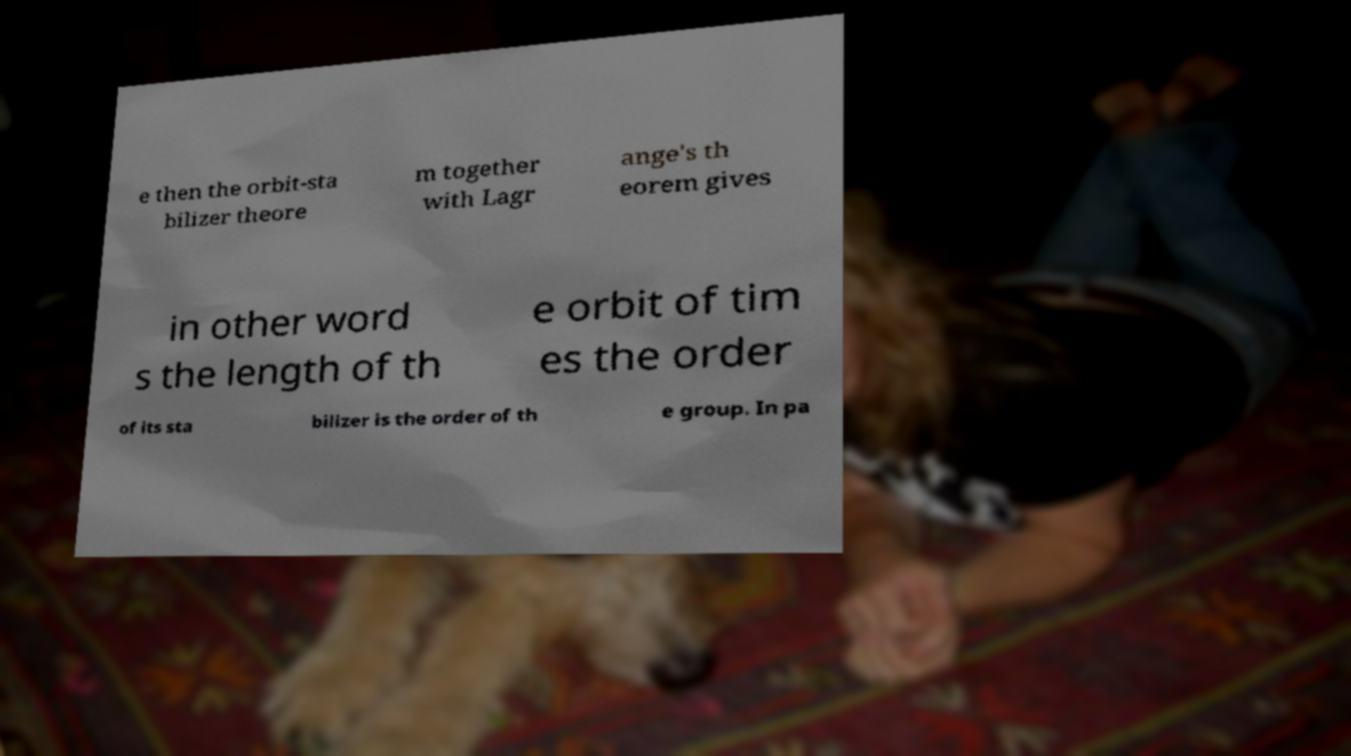Please read and relay the text visible in this image. What does it say? e then the orbit-sta bilizer theore m together with Lagr ange's th eorem gives in other word s the length of th e orbit of tim es the order of its sta bilizer is the order of th e group. In pa 